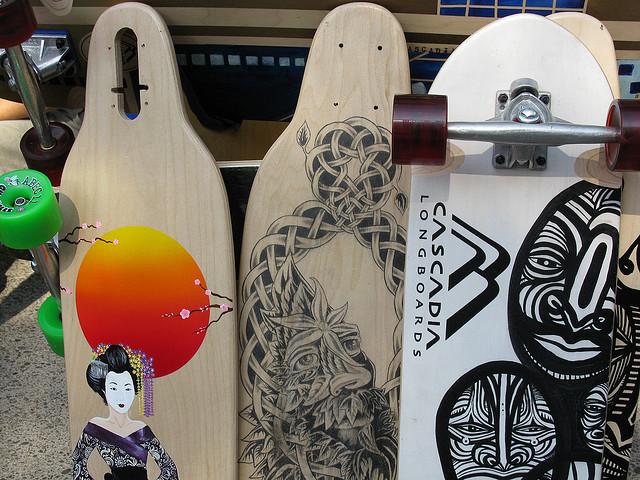Do all the skateboards have wheels?
Give a very brief answer. No. Which one features a Japanese woman?
Be succinct. Left. How many skateboards are in the picture?
Keep it brief. 3. 